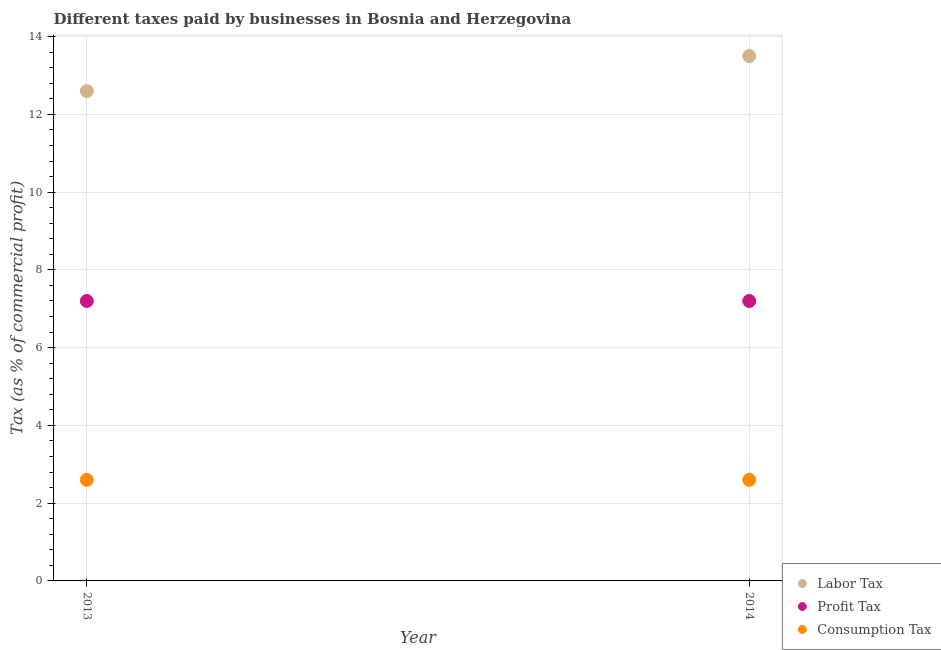Is the number of dotlines equal to the number of legend labels?
Provide a succinct answer. Yes. Across all years, what is the maximum percentage of consumption tax?
Offer a terse response. 2.6. Across all years, what is the minimum percentage of consumption tax?
Ensure brevity in your answer.  2.6. In which year was the percentage of consumption tax maximum?
Your answer should be compact. 2013. What is the total percentage of profit tax in the graph?
Keep it short and to the point. 14.4. What is the difference between the percentage of labor tax in 2013 and that in 2014?
Provide a short and direct response. -0.9. What is the difference between the percentage of profit tax in 2014 and the percentage of labor tax in 2013?
Provide a succinct answer. -5.4. What is the average percentage of labor tax per year?
Offer a very short reply. 13.05. What is the ratio of the percentage of labor tax in 2013 to that in 2014?
Your response must be concise. 0.93. Is the percentage of profit tax in 2013 less than that in 2014?
Offer a terse response. No. In how many years, is the percentage of profit tax greater than the average percentage of profit tax taken over all years?
Offer a very short reply. 0. Is it the case that in every year, the sum of the percentage of labor tax and percentage of profit tax is greater than the percentage of consumption tax?
Your answer should be compact. Yes. Is the percentage of labor tax strictly greater than the percentage of profit tax over the years?
Keep it short and to the point. Yes. How many dotlines are there?
Provide a short and direct response. 3. How many years are there in the graph?
Provide a succinct answer. 2. Does the graph contain any zero values?
Your response must be concise. No. Where does the legend appear in the graph?
Keep it short and to the point. Bottom right. How many legend labels are there?
Offer a terse response. 3. How are the legend labels stacked?
Provide a short and direct response. Vertical. What is the title of the graph?
Your answer should be compact. Different taxes paid by businesses in Bosnia and Herzegovina. What is the label or title of the Y-axis?
Your response must be concise. Tax (as % of commercial profit). What is the Tax (as % of commercial profit) of Profit Tax in 2013?
Make the answer very short. 7.2. What is the Tax (as % of commercial profit) of Consumption Tax in 2014?
Give a very brief answer. 2.6. Across all years, what is the maximum Tax (as % of commercial profit) of Labor Tax?
Your answer should be compact. 13.5. Across all years, what is the maximum Tax (as % of commercial profit) of Profit Tax?
Keep it short and to the point. 7.2. Across all years, what is the maximum Tax (as % of commercial profit) of Consumption Tax?
Your response must be concise. 2.6. Across all years, what is the minimum Tax (as % of commercial profit) in Labor Tax?
Your answer should be compact. 12.6. What is the total Tax (as % of commercial profit) of Labor Tax in the graph?
Your answer should be very brief. 26.1. What is the total Tax (as % of commercial profit) in Consumption Tax in the graph?
Your response must be concise. 5.2. What is the difference between the Tax (as % of commercial profit) in Labor Tax in 2013 and that in 2014?
Give a very brief answer. -0.9. What is the difference between the Tax (as % of commercial profit) in Labor Tax in 2013 and the Tax (as % of commercial profit) in Profit Tax in 2014?
Ensure brevity in your answer.  5.4. What is the average Tax (as % of commercial profit) of Labor Tax per year?
Offer a terse response. 13.05. What is the average Tax (as % of commercial profit) of Profit Tax per year?
Make the answer very short. 7.2. In the year 2013, what is the difference between the Tax (as % of commercial profit) of Labor Tax and Tax (as % of commercial profit) of Consumption Tax?
Your response must be concise. 10. What is the ratio of the Tax (as % of commercial profit) in Labor Tax in 2013 to that in 2014?
Your answer should be compact. 0.93. What is the ratio of the Tax (as % of commercial profit) of Profit Tax in 2013 to that in 2014?
Your answer should be compact. 1. What is the ratio of the Tax (as % of commercial profit) of Consumption Tax in 2013 to that in 2014?
Provide a succinct answer. 1. What is the difference between the highest and the second highest Tax (as % of commercial profit) in Labor Tax?
Ensure brevity in your answer.  0.9. What is the difference between the highest and the lowest Tax (as % of commercial profit) of Labor Tax?
Ensure brevity in your answer.  0.9. 